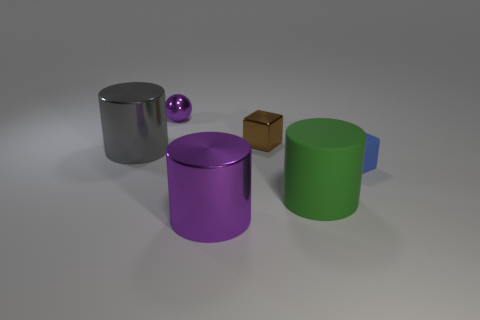There is a object that is both behind the green matte cylinder and in front of the large gray object; what is its material?
Your response must be concise. Rubber. Are there fewer tiny metallic cubes on the left side of the purple cylinder than small blocks right of the small brown shiny block?
Offer a very short reply. Yes. What is the size of the cylinder that is the same material as the big purple thing?
Keep it short and to the point. Large. Is there anything else of the same color as the ball?
Ensure brevity in your answer.  Yes. Do the small purple ball and the purple object that is in front of the tiny purple sphere have the same material?
Provide a succinct answer. Yes. What material is the green object that is the same shape as the big gray object?
Provide a short and direct response. Rubber. Is the big object behind the blue object made of the same material as the tiny blue block in front of the tiny purple shiny ball?
Your answer should be very brief. No. The large object on the left side of the small metal object left of the purple thing that is in front of the small purple metal thing is what color?
Your response must be concise. Gray. What number of other objects are the same shape as the small brown thing?
Offer a very short reply. 1. How many objects are either large red cylinders or objects that are behind the large purple thing?
Give a very brief answer. 5. 